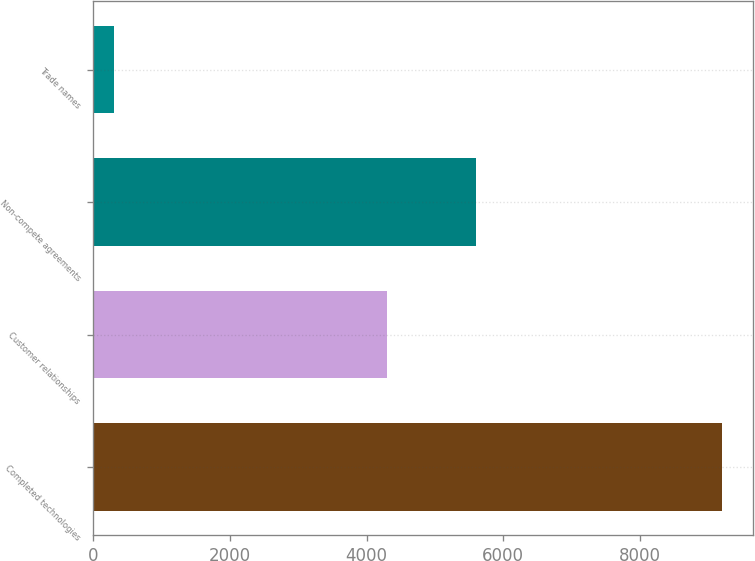Convert chart. <chart><loc_0><loc_0><loc_500><loc_500><bar_chart><fcel>Completed technologies<fcel>Customer relationships<fcel>Non-compete agreements<fcel>Trade names<nl><fcel>9200<fcel>4300<fcel>5600<fcel>300<nl></chart> 